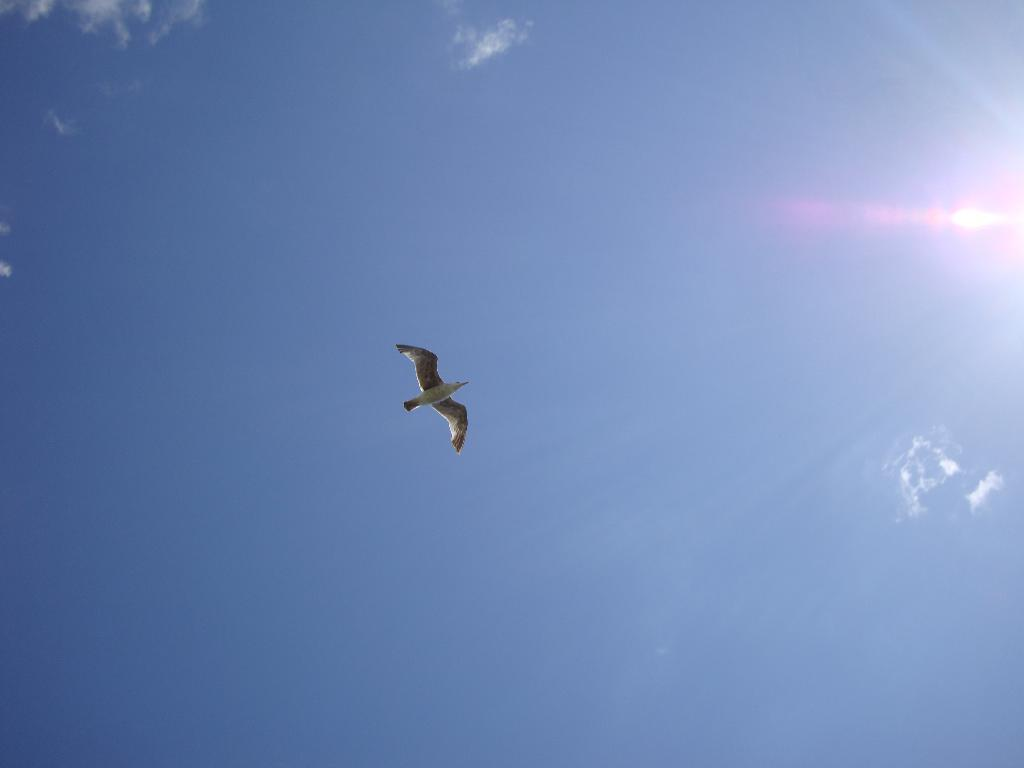What type of animal is in the image? There is a bird in the image. What colors can be seen on the bird? The bird is white and black in color. What is the bird doing in the image? The bird is flying. What can be seen in the background of the image? The sky is visible in the image. What colors are present in the sky? The sky is white and blue in color. What type of corn can be seen growing in the wilderness in the image? There is no corn or wilderness present in the image; it features a bird flying in the sky. 